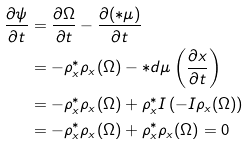<formula> <loc_0><loc_0><loc_500><loc_500>\frac { \partial \psi } { \partial t } & = \frac { \partial \Omega } { \partial t } - \frac { \partial ( * \mu ) } { \partial t } \\ & = - \rho _ { x } ^ { * } \rho _ { x } ( \Omega ) - * d \mu \left ( \frac { \partial x } { \partial t } \right ) \\ & = - \rho _ { x } ^ { * } \rho _ { x } ( \Omega ) + \rho _ { x } ^ { * } I \left ( - I \rho _ { x } ( \Omega ) \right ) \\ & = - \rho _ { x } ^ { * } \rho _ { x } ( \Omega ) + \rho _ { x } ^ { * } \rho _ { x } ( \Omega ) = 0</formula> 